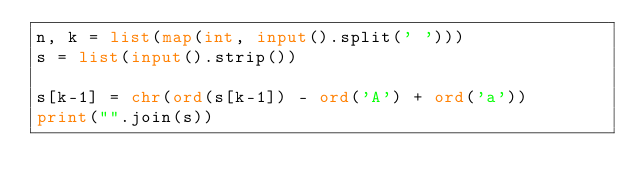<code> <loc_0><loc_0><loc_500><loc_500><_Python_>n, k = list(map(int, input().split(' ')))
s = list(input().strip())

s[k-1] = chr(ord(s[k-1]) - ord('A') + ord('a'))
print("".join(s))</code> 